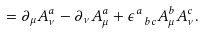<formula> <loc_0><loc_0><loc_500><loc_500>= \partial _ { \mu } A _ { \nu } ^ { a } - \partial _ { \nu } A _ { \mu } ^ { a } + \epsilon _ { \ b c } ^ { a } A _ { \mu } ^ { b } A _ { \nu } ^ { c } .</formula> 